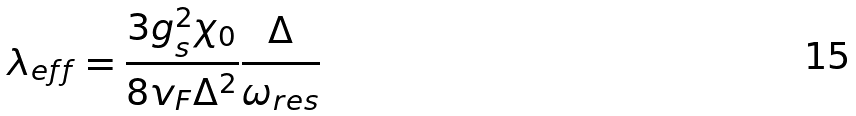<formula> <loc_0><loc_0><loc_500><loc_500>\lambda _ { e f f } = \frac { 3 g _ { s } ^ { 2 } \chi _ { 0 } } { 8 v _ { F } \Delta ^ { 2 } } \frac { \Delta } { \omega _ { r e s } }</formula> 